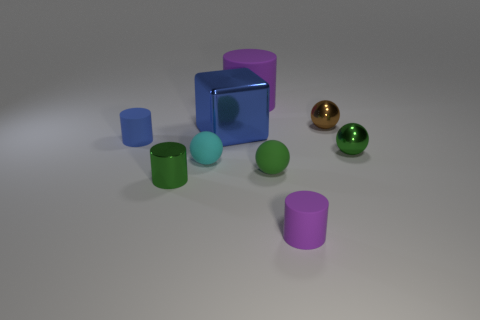Are there any cyan objects to the left of the tiny cyan object? No, there are no cyan objects to the left of the tiny cyan object. To the left side, you can only find objects of different colors, like magenta and green. 